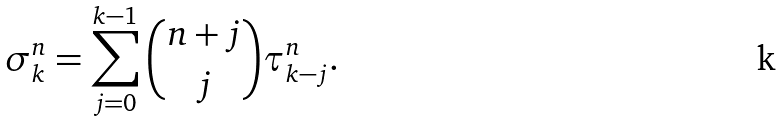<formula> <loc_0><loc_0><loc_500><loc_500>\sigma _ { k } ^ { n } = \sum _ { j = 0 } ^ { k - 1 } { n + j \choose j } \tau ^ { n } _ { k - j } .</formula> 